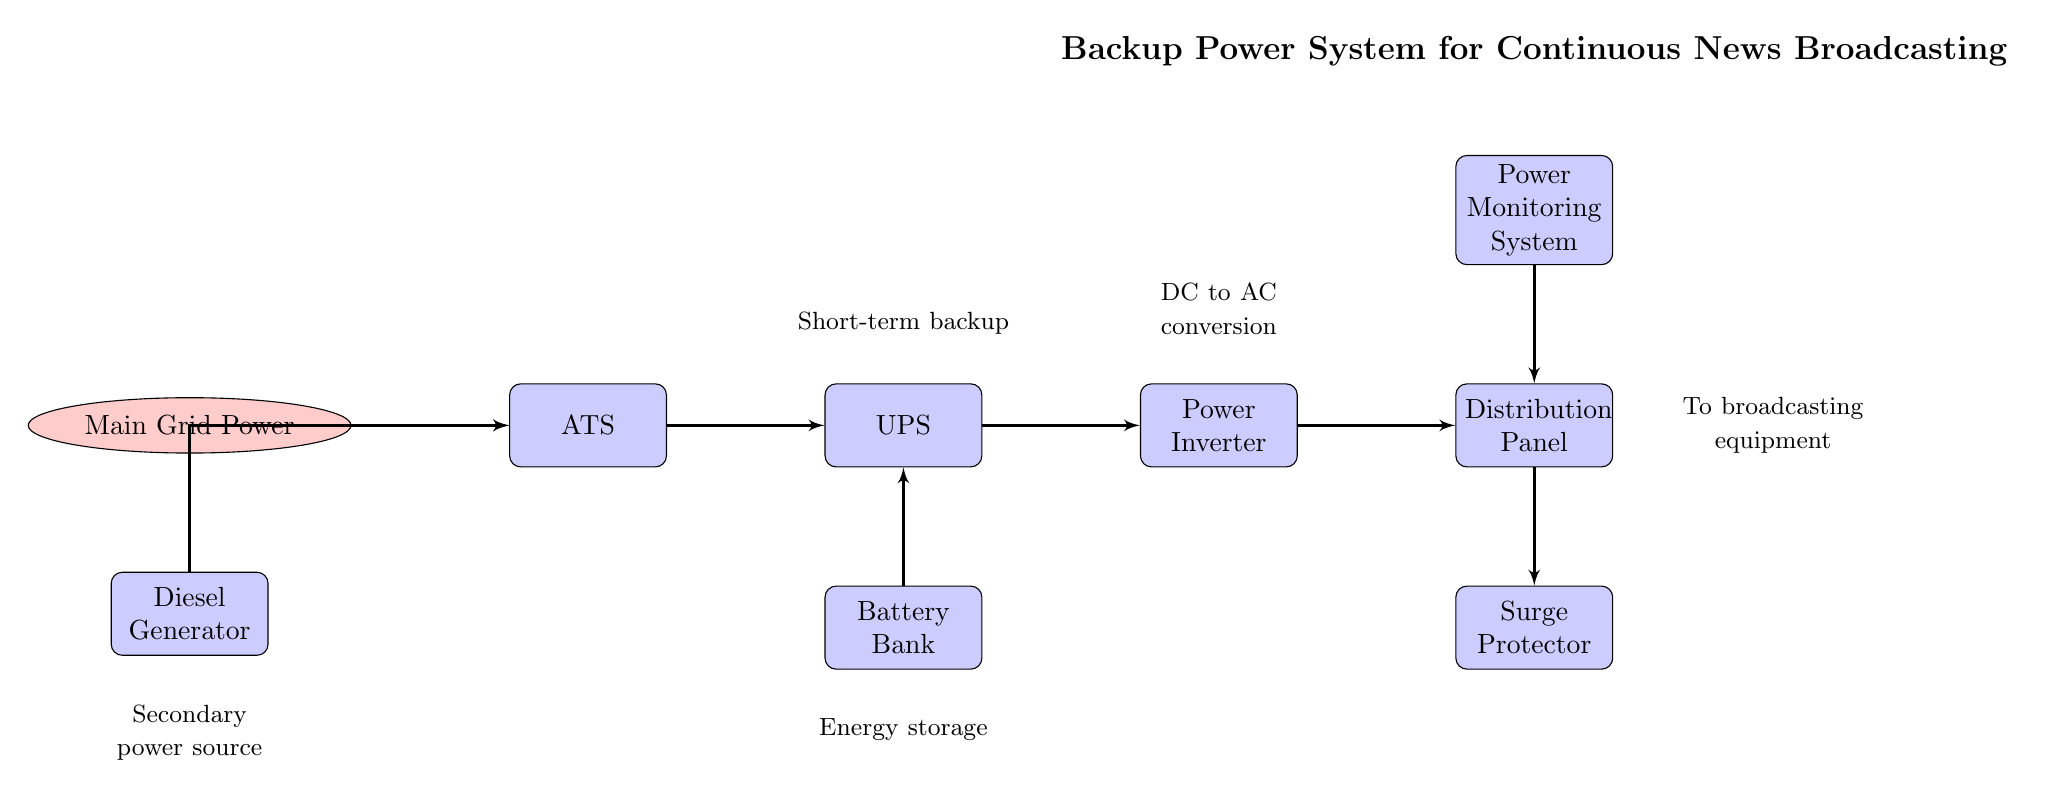What is the primary power source in this circuit? The diagram indicates "Main Grid Power" as the top cloud node, representing the primary source of power for the backup system.
Answer: Main Grid Power How many nodes are present in the diagram? By counting all the distinct shapes (clouds and blocks), there are a total of 8 nodes listed: 1 cloud (Main Grid Power) and 7 blocks.
Answer: 8 Which component is responsible for converting DC to AC? The diagram shows the "Power Inverter" as the component that connects the battery bank to the distribution panel and is labeled for DC to AC conversion.
Answer: Power Inverter What connects the Diesel Generator to the ATS? The diagram illustrates a line that connects the "Diesel Generator" directly to the "ATS", indicating that the ATS can switch to the diesel generator as an alternative power source.
Answer: ATS What is the function of the UPS in the circuit? The "UPS" (Uninterruptible Power Supply) is positioned in the diagram to provide short-term backup power; hence, it supports the operational continuity of systems during power interruption.
Answer: Short-term backup If the main grid power fails, which node provides secondary power? The "Diesel Generator" acts as a secondary power source and connects to the ATS, which can switch power sources accordingly in case of a failure.
Answer: Diesel Generator What type of component is placed below the UPS? Below the "UPS", according to the diagram, is the "Battery Bank," which serves as an energy storage element to support the UPS in providing backup power.
Answer: Battery Bank What is placed after the Distribution Panel in the flow? Following the "Distribution Panel", there is a "Surge Protector" as depicted in the diagram, designed to protect the broadcasting equipment from voltage spikes.
Answer: Surge Protector How does the Power Monitoring System connect to the circuit? The "Power Monitoring System" connects directly to the "Distribution Panel" above, indicating its role in overseeing the power flow to the broadcasting equipment.
Answer: Distribution Panel 